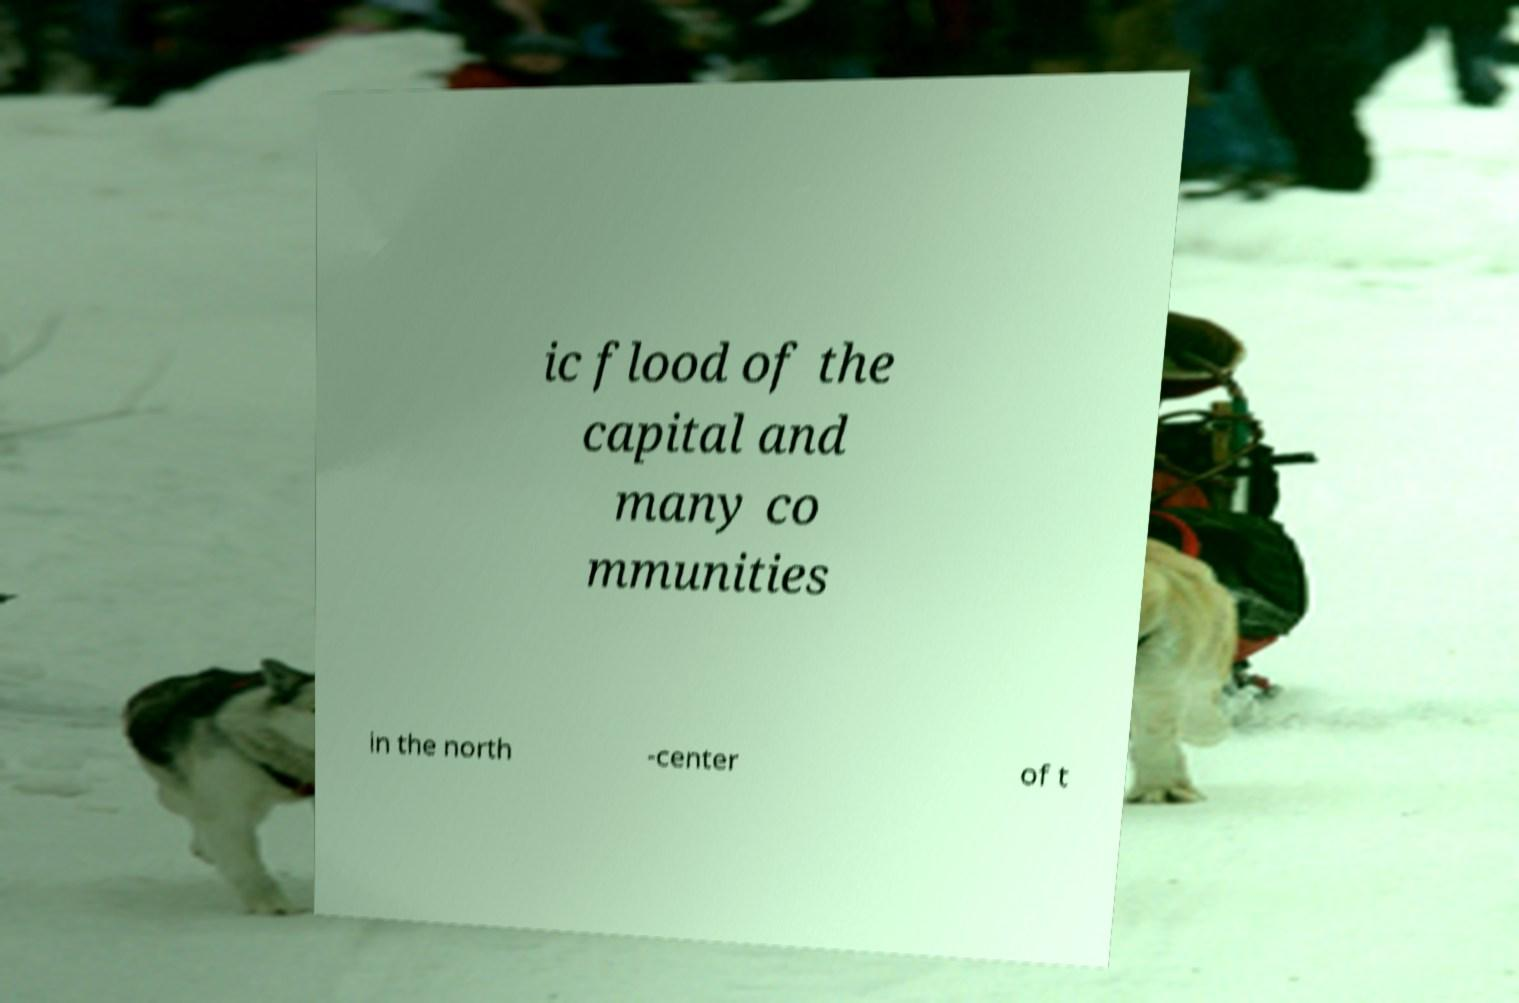Can you accurately transcribe the text from the provided image for me? ic flood of the capital and many co mmunities in the north -center of t 